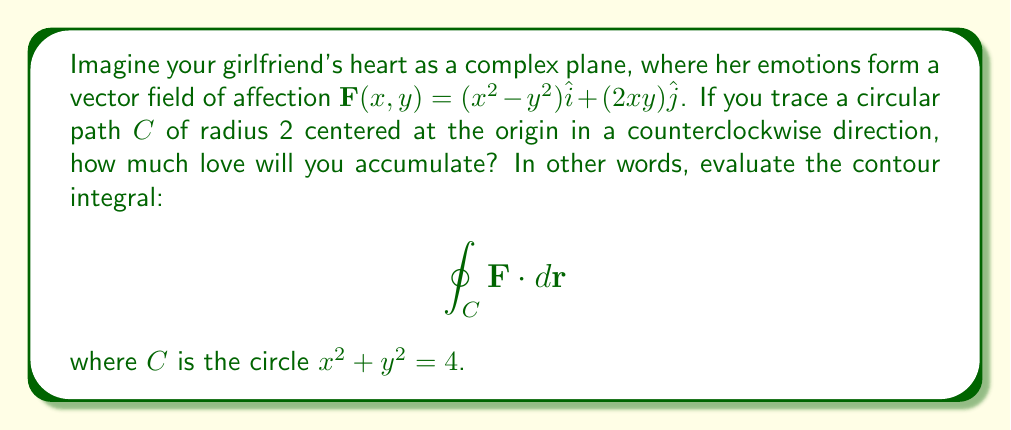Solve this math problem. Let's approach this step-by-step:

1) First, we need to parameterize the circular path. We can use:
   $x = 2\cos\theta$, $y = 2\sin\theta$, where $0 \leq \theta \leq 2\pi$

2) Now, we need to express $dx$ and $dy$ in terms of $d\theta$:
   $dx = -2\sin\theta d\theta$, $dy = 2\cos\theta d\theta$

3) We can now write the contour integral as:

   $$\oint_C \mathbf{F} \cdot d\mathbf{r} = \int_0^{2\pi} [(x^2-y^2)dx + (2xy)dy]$$

4) Substituting our parameterization:

   $$\int_0^{2\pi} [(4\cos^2\theta - 4\sin^2\theta)(-2\sin\theta) + (2(2\cos\theta)(2\sin\theta))(2\cos\theta)] d\theta$$

5) Simplifying:

   $$\int_0^{2\pi} [-8\cos^2\theta\sin\theta + 8\sin^3\theta + 16\cos^2\theta\sin\theta] d\theta$$
   $$= \int_0^{2\pi} [8\cos^2\theta\sin\theta + 8\sin^3\theta] d\theta$$

6) We can use the identity $\cos^2\theta = \frac{1+\cos2\theta}{2}$:

   $$= \int_0^{2\pi} [4(1+\cos2\theta)\sin\theta + 8\sin^3\theta] d\theta$$

7) Using the substitution $u = \cos\theta$, $du = -\sin\theta d\theta$:

   $$= -4\int_1^1 (1+2u^2-1)du - 8\int_1^1 (1-u^2)du$$
   $$= -8\int_1^1 u^2du + 8\int_1^1 u^2du - 8\int_1^1 du$$
   $$= -8\int_1^1 du = 0$$

The contour integral evaluates to zero, which means the total accumulation of love around this closed path is zero.
Answer: 0 